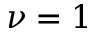<formula> <loc_0><loc_0><loc_500><loc_500>\nu = 1</formula> 